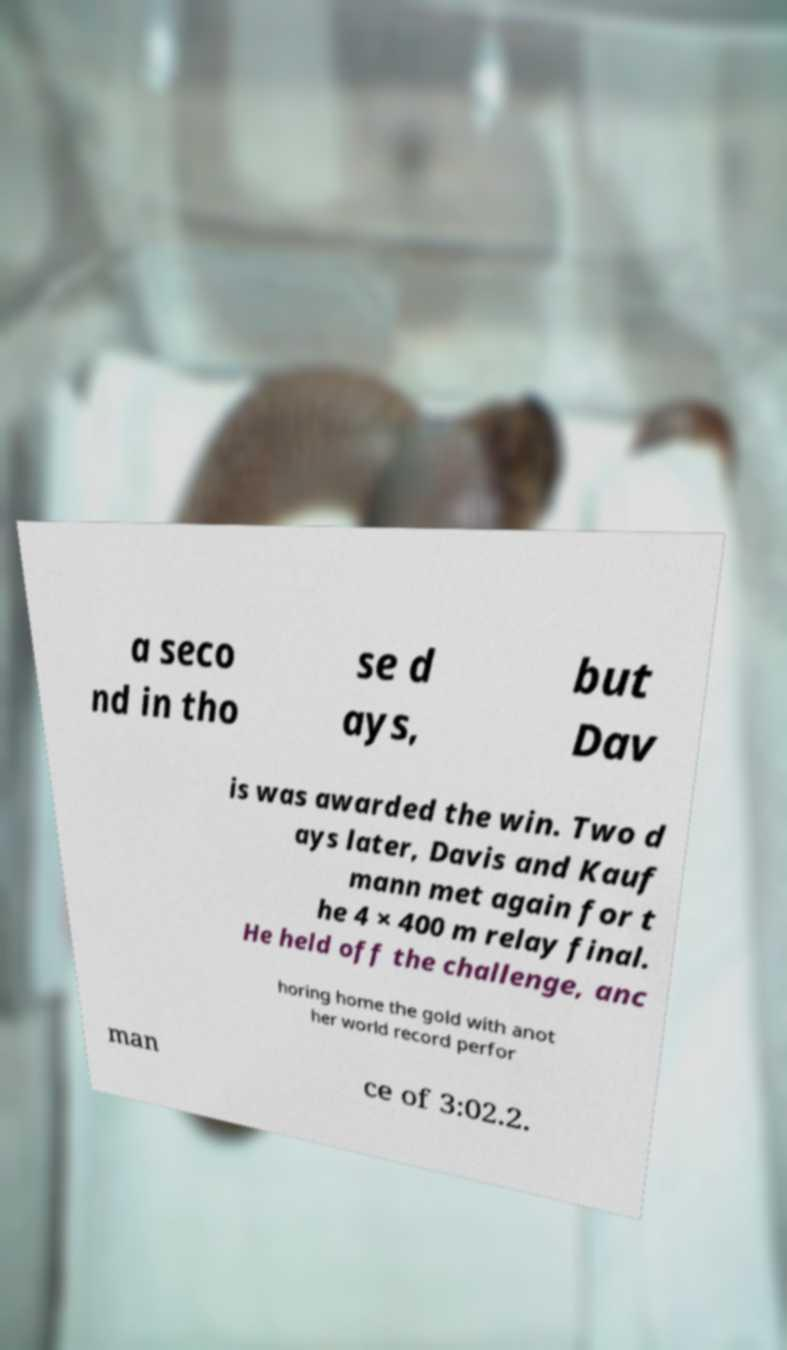Could you assist in decoding the text presented in this image and type it out clearly? a seco nd in tho se d ays, but Dav is was awarded the win. Two d ays later, Davis and Kauf mann met again for t he 4 × 400 m relay final. He held off the challenge, anc horing home the gold with anot her world record perfor man ce of 3:02.2. 